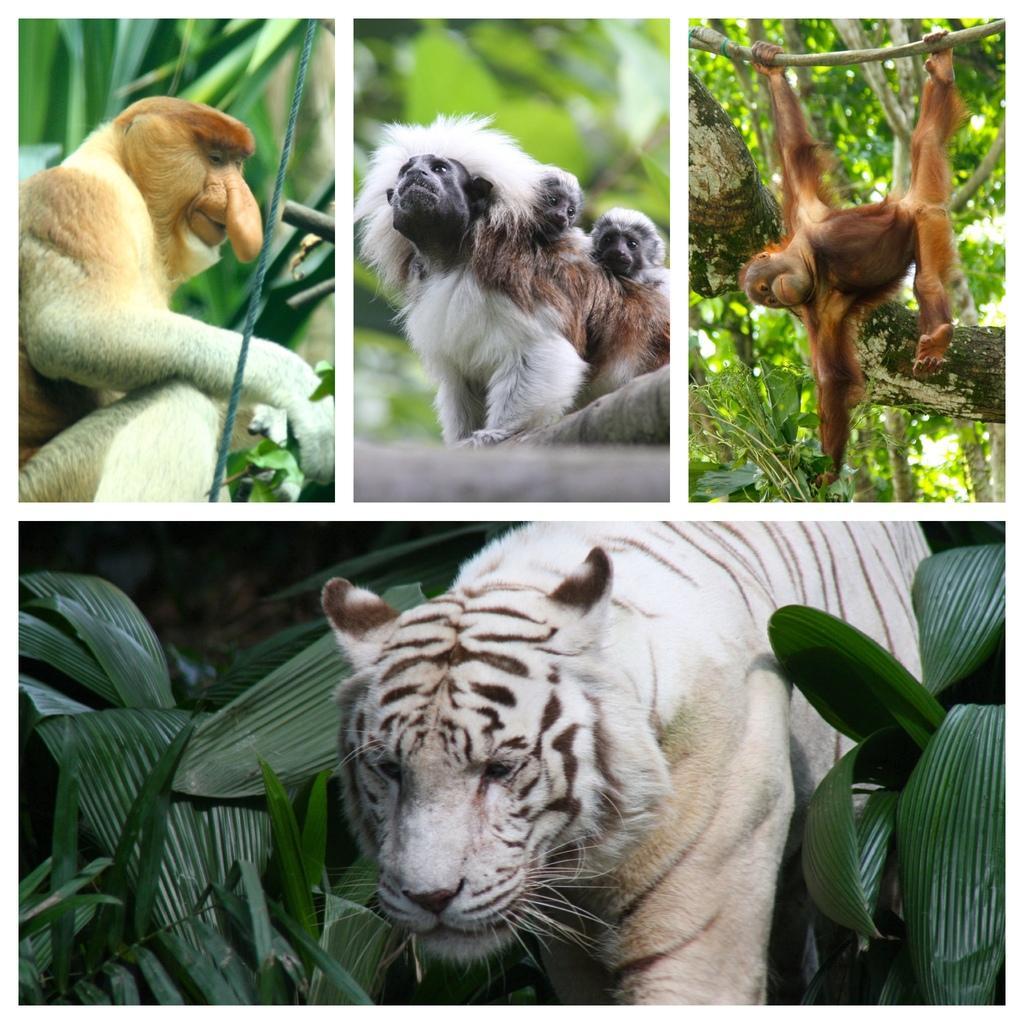What type of artwork is the image? The image is a collage. What types of living organisms can be seen in the image? Animals and trees can be seen in the image. What other elements are present in the image besides animals and trees? Plants are also present in the image. What type of horn can be seen on the horses in the image? There are no horses present in the image, and therefore no horns can be observed. What type of ground is visible in the image? The image is a collage, and it does not depict a specific ground or terrain. 